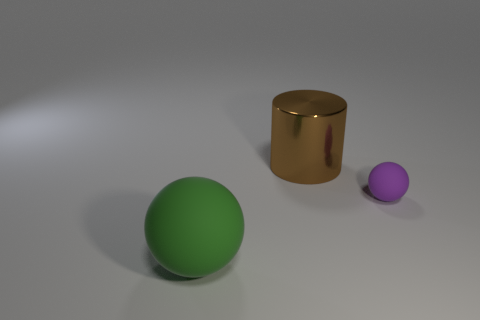Add 3 green spheres. How many objects exist? 6 Subtract all cylinders. How many objects are left? 2 Subtract all brown cylinders. Subtract all tiny rubber balls. How many objects are left? 1 Add 1 large things. How many large things are left? 3 Add 2 large cyan metal cubes. How many large cyan metal cubes exist? 2 Subtract 0 green cylinders. How many objects are left? 3 